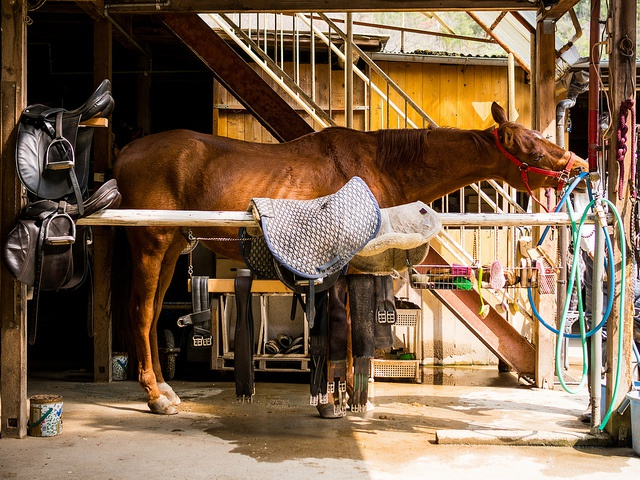Describe the objects in this image and their specific colors. I can see a horse in black, maroon, and brown tones in this image. 